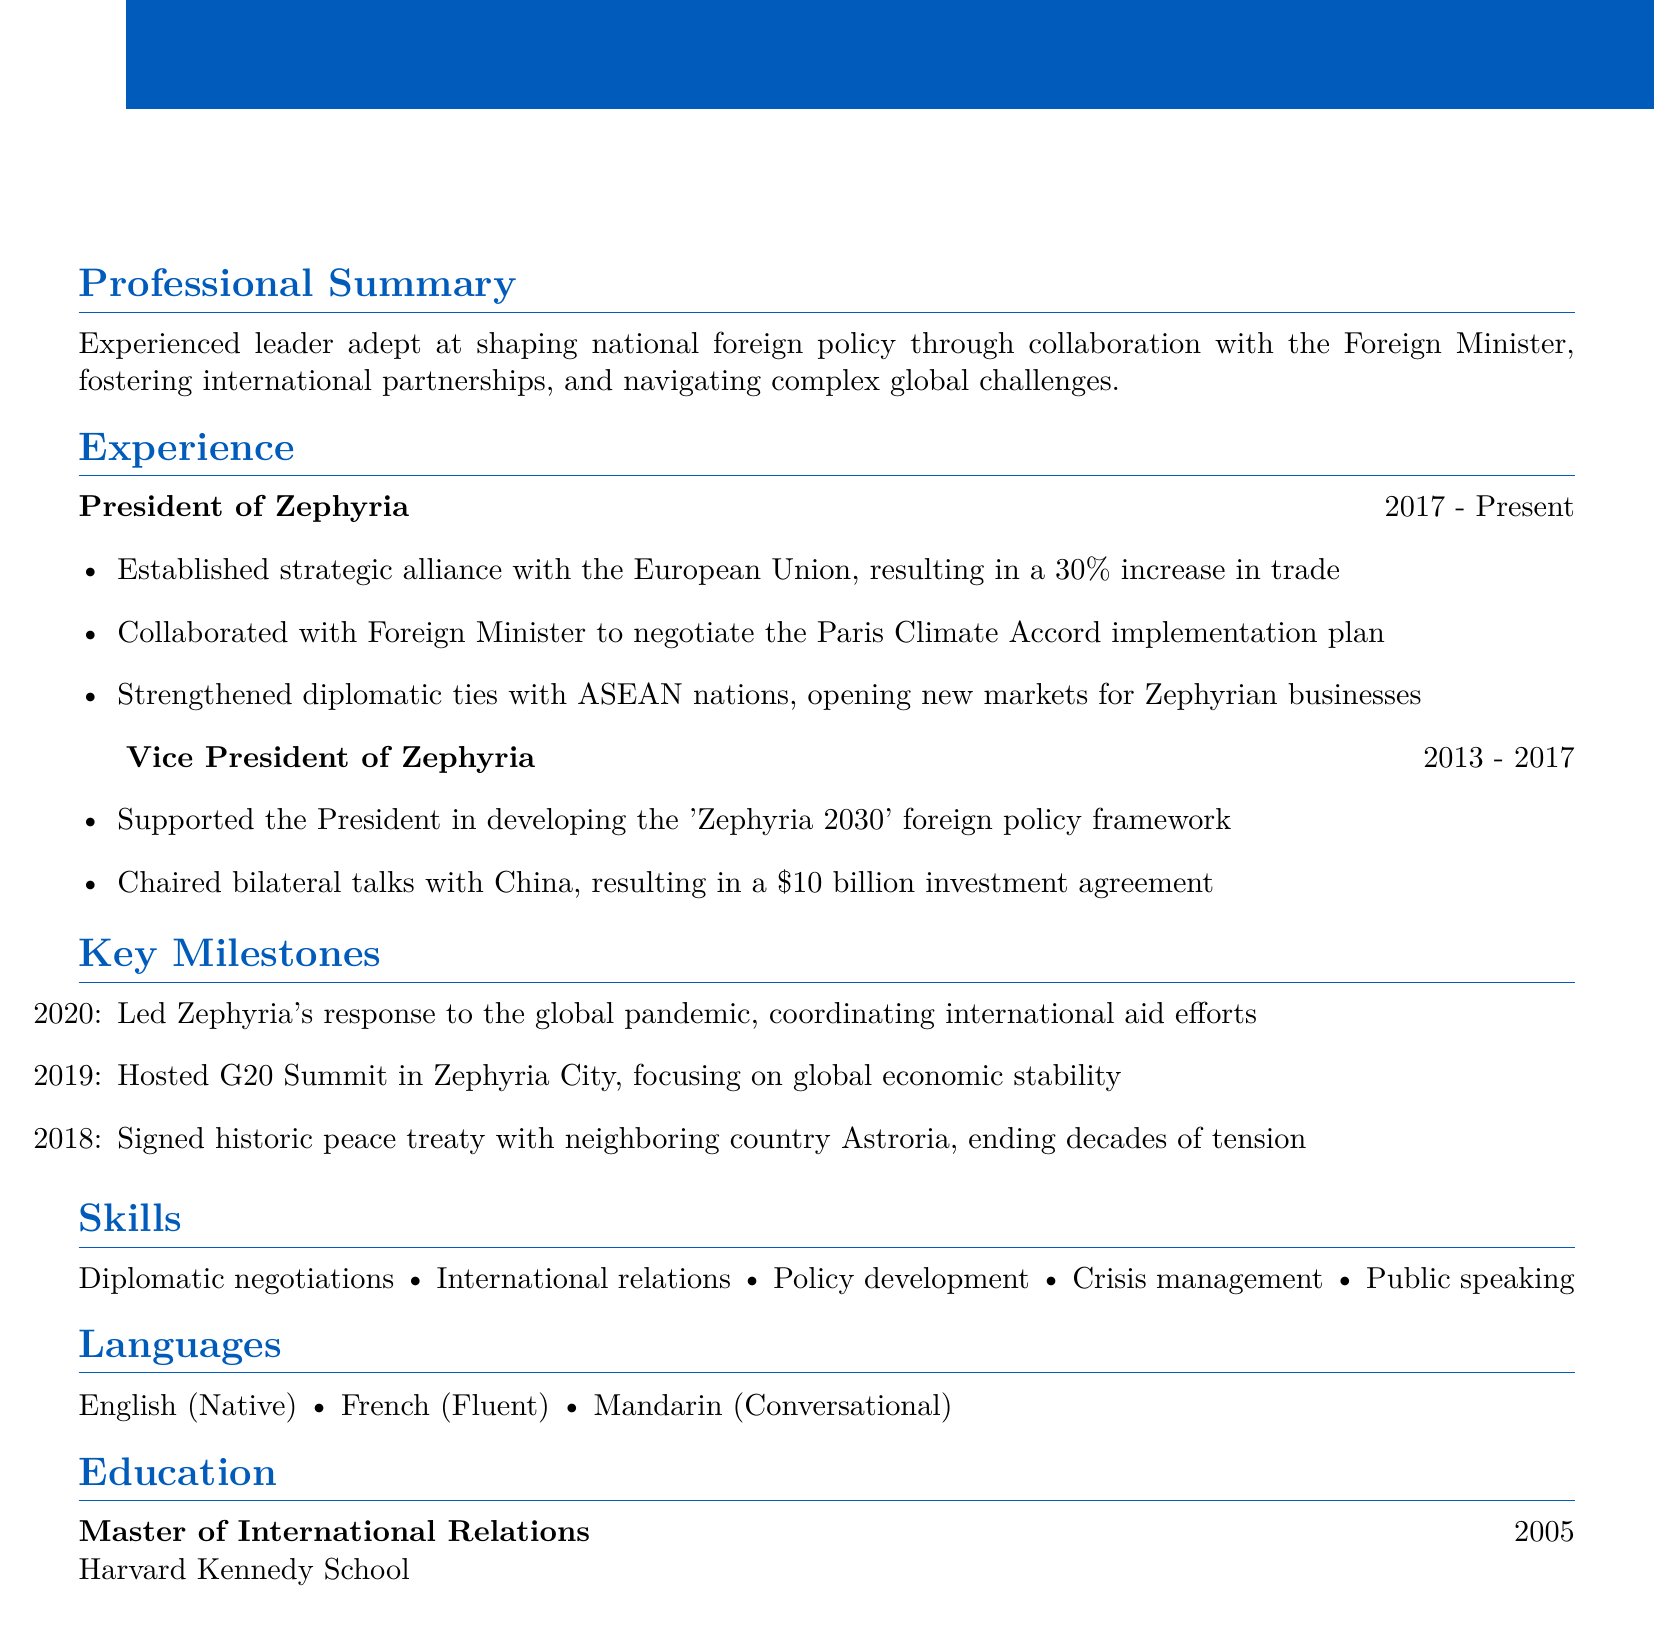What is the name of the president? The document lists Alexandra Thompson as the current President of Zephyria.
Answer: Alexandra Thompson What title did Alexandra Thompson hold before becoming president? The resume indicates that she served as Vice President of Zephyria prior to her presidency.
Answer: Vice President of Zephyria In which year did Alexandra Thompson start her presidency? The experience section shows that she became President in 2017.
Answer: 2017 What significant event did she host in 2019? The key milestones detail that she hosted the G20 Summit in Zephyria City that year.
Answer: G20 Summit How much did the bilateral talks with China result in for Zephyria? The achievements list states that the talks led to a $10 billion investment agreement.
Answer: $10 billion Which degree did Alexandra Thompson earn, and from which institution? The education section specifies that she holds a Master's degree in International Relations from Harvard Kennedy School.
Answer: Master of International Relations; Harvard Kennedy School How did the trade with the European Union change after establishing the strategic alliance? The achievements state there was a 30% increase in trade following the alliance.
Answer: 30% increase What is one of Alexandra Thompson's language skills? The languages section lists her proficiency in multiple languages, including French.
Answer: French What was one of the key focuses of the G20 Summit hosted by Alexandra Thompson? The document notes that the summit focused on global economic stability.
Answer: Global economic stability 